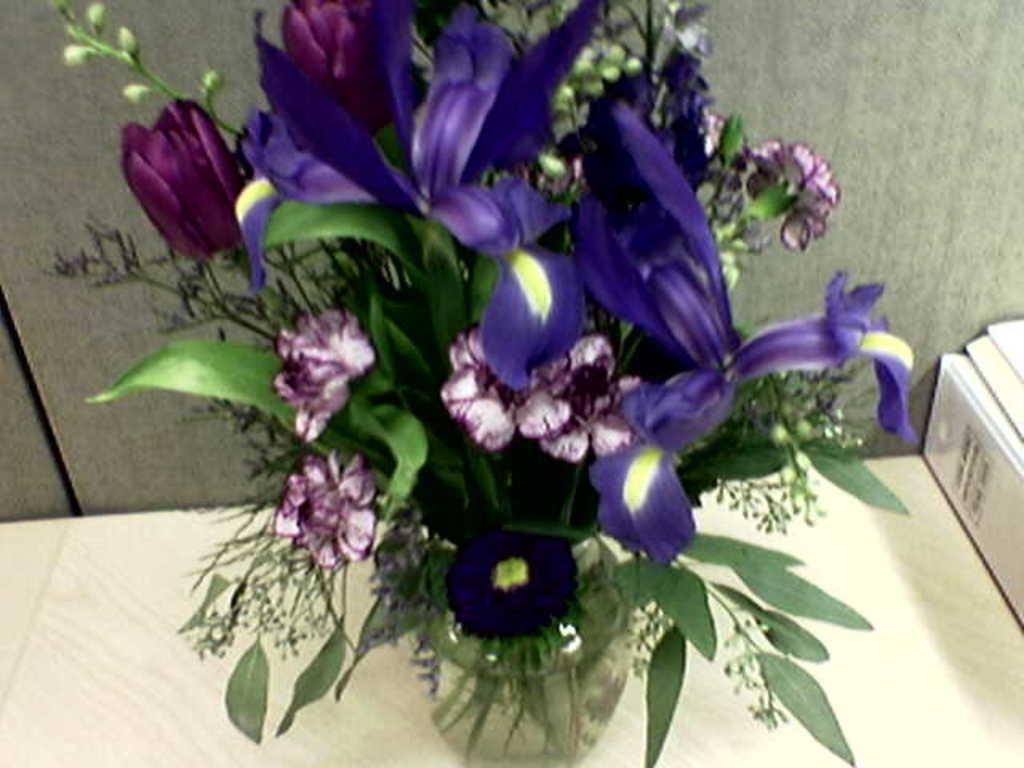What piece of furniture is present in the image? There is a table in the image. What is placed on the table? There is a flower vase on the table. What is inside the flower vase? The flower vase contains leaves and flowers. What can be seen in the background of the image? There is a wall in the background of the image. Where is the throne located in the image? There is no throne present in the image. What type of music is being played by the band in the image? There is no band present in the image. 